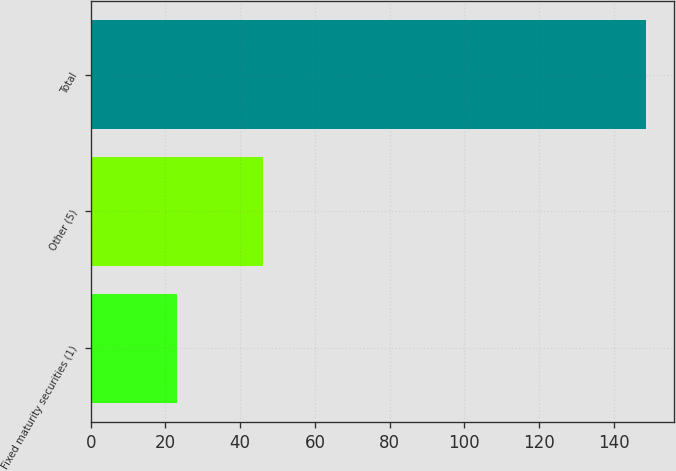Convert chart. <chart><loc_0><loc_0><loc_500><loc_500><bar_chart><fcel>Fixed maturity securities (1)<fcel>Other (5)<fcel>Total<nl><fcel>23.1<fcel>46<fcel>148.7<nl></chart> 